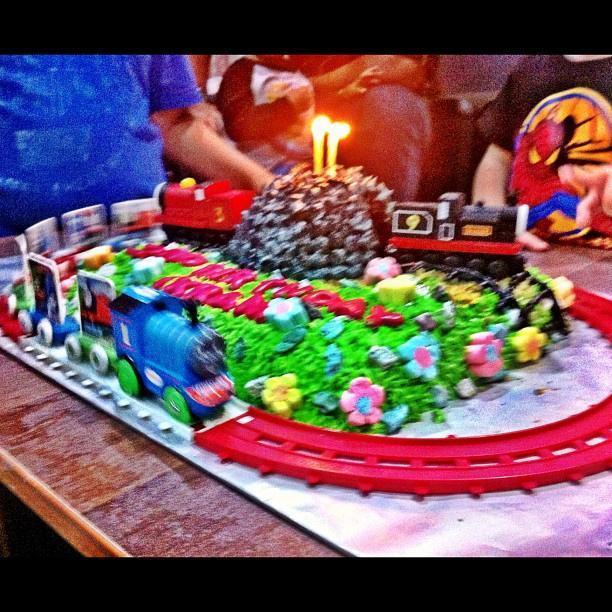How many people are there?
Give a very brief answer. 3. How many trains are there?
Give a very brief answer. 2. 